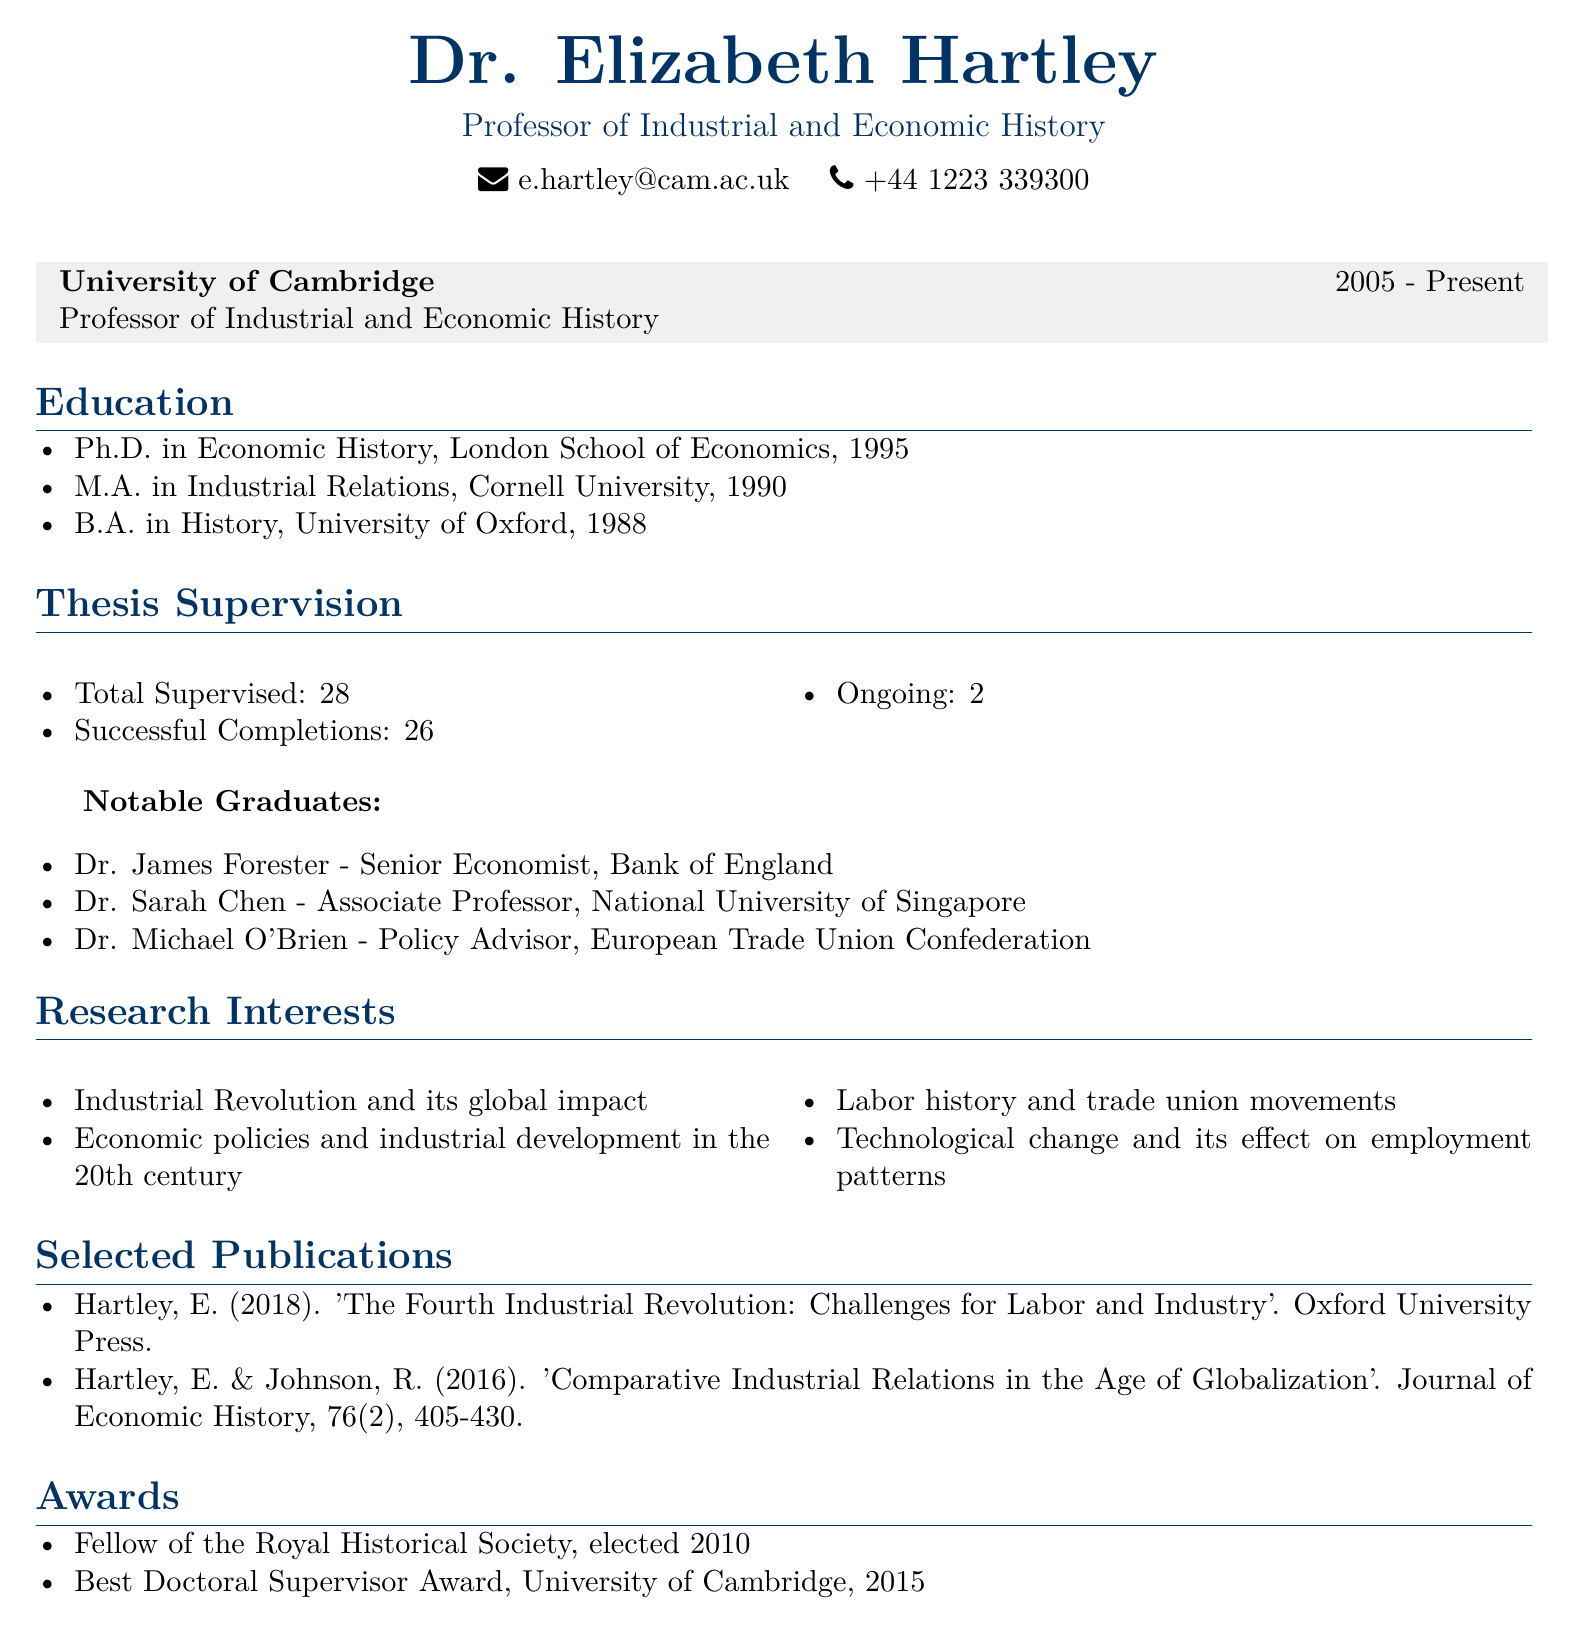What is the title of Dr. Elizabeth Hartley? The title of Dr. Elizabeth Hartley is listed as "Professor of Industrial and Economic History".
Answer: Professor of Industrial and Economic History What institution does Dr. Elizabeth Hartley work for? The document states that Dr. Hartley is affiliated with the University of Cambridge.
Answer: University of Cambridge How many doctoral theses has Dr. Hartley supervised? The total number of doctoral theses supervised by Dr. Hartley is explicitly mentioned in the document as 28.
Answer: 28 What year did Dr. Hartley complete her Ph.D.? The document specifies that Dr. Hartley completed her Ph.D. in Economic History in 1995.
Answer: 1995 Which award did Dr. Hartley receive in 2015? The document mentions that she received the "Best Doctoral Supervisor Award" from the University of Cambridge in 2015.
Answer: Best Doctoral Supervisor Award Who is one of Dr. Hartley's notable graduates and their current position? Dr. James Forester is mentioned as a notable graduate and is currently a Senior Economist at the Bank of England.
Answer: Dr. James Forester - Senior Economist, Bank of England What is one of Dr. Hartley's primary research interests? The document lists several research interests; one of them is the "Industrial Revolution and its global impact".
Answer: Industrial Revolution and its global impact Where did Dr. Hartley earn her M.A. degree? According to the document, Dr. Hartley earned her M.A. in Industrial Relations from Cornell University.
Answer: Cornell University How many successful completions of theses did Dr. Hartley have? The document states that out of 28 supervised theses, there were 26 successful completions.
Answer: 26 